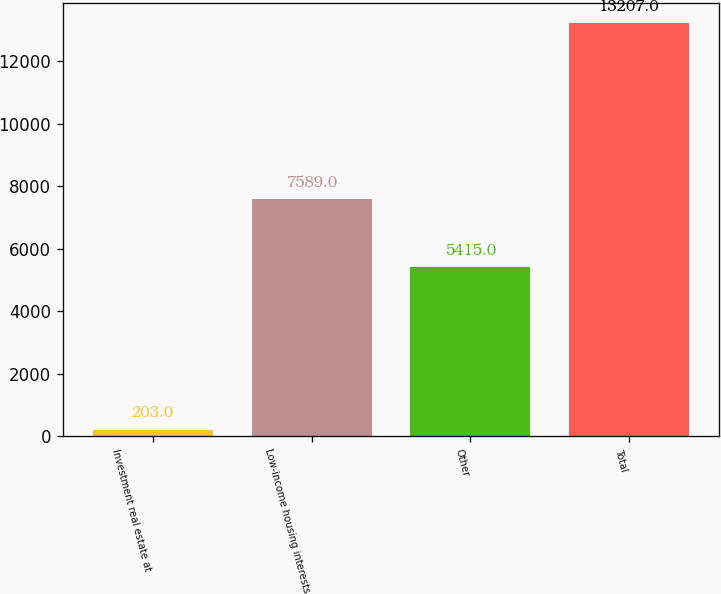Convert chart to OTSL. <chart><loc_0><loc_0><loc_500><loc_500><bar_chart><fcel>Investment real estate at<fcel>Low-income housing interests<fcel>Other<fcel>Total<nl><fcel>203<fcel>7589<fcel>5415<fcel>13207<nl></chart> 